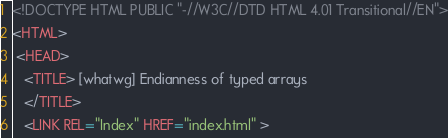Convert code to text. <code><loc_0><loc_0><loc_500><loc_500><_HTML_><!DOCTYPE HTML PUBLIC "-//W3C//DTD HTML 4.01 Transitional//EN">
<HTML>
 <HEAD>
   <TITLE> [whatwg] Endianness of typed arrays
   </TITLE>
   <LINK REL="Index" HREF="index.html" ></code> 